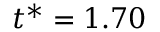Convert formula to latex. <formula><loc_0><loc_0><loc_500><loc_500>t ^ { * } = 1 . 7 0</formula> 